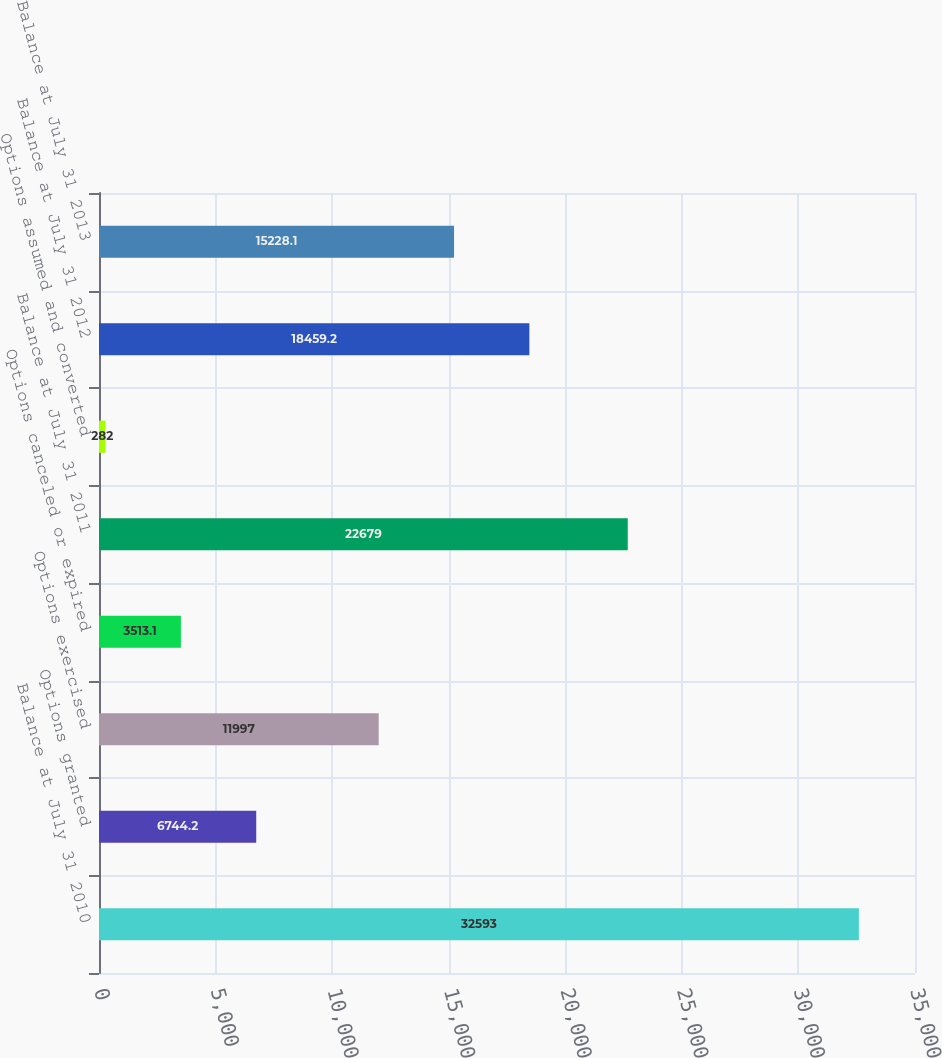Convert chart to OTSL. <chart><loc_0><loc_0><loc_500><loc_500><bar_chart><fcel>Balance at July 31 2010<fcel>Options granted<fcel>Options exercised<fcel>Options canceled or expired<fcel>Balance at July 31 2011<fcel>Options assumed and converted<fcel>Balance at July 31 2012<fcel>Balance at July 31 2013<nl><fcel>32593<fcel>6744.2<fcel>11997<fcel>3513.1<fcel>22679<fcel>282<fcel>18459.2<fcel>15228.1<nl></chart> 